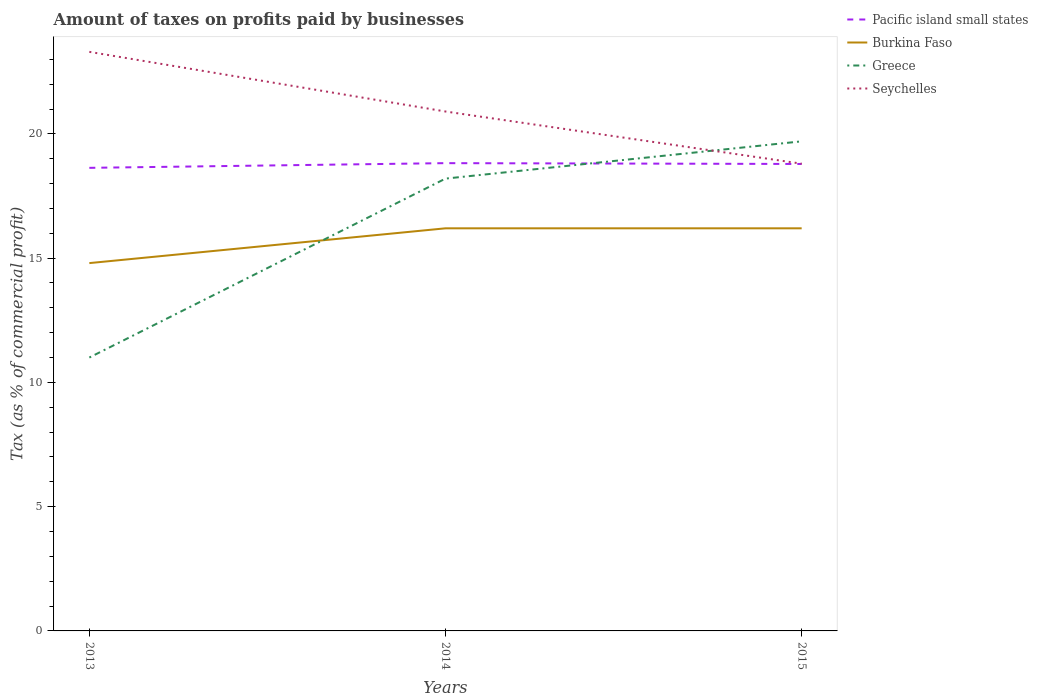Across all years, what is the maximum percentage of taxes paid by businesses in Greece?
Give a very brief answer. 11. In which year was the percentage of taxes paid by businesses in Seychelles maximum?
Offer a terse response. 2015. What is the total percentage of taxes paid by businesses in Seychelles in the graph?
Your answer should be very brief. 4.5. What is the difference between the highest and the second highest percentage of taxes paid by businesses in Burkina Faso?
Your answer should be compact. 1.4. What is the difference between the highest and the lowest percentage of taxes paid by businesses in Pacific island small states?
Give a very brief answer. 2. Is the percentage of taxes paid by businesses in Seychelles strictly greater than the percentage of taxes paid by businesses in Pacific island small states over the years?
Make the answer very short. No. Does the graph contain any zero values?
Your answer should be compact. No. Does the graph contain grids?
Give a very brief answer. No. How many legend labels are there?
Ensure brevity in your answer.  4. How are the legend labels stacked?
Your response must be concise. Vertical. What is the title of the graph?
Offer a terse response. Amount of taxes on profits paid by businesses. What is the label or title of the Y-axis?
Offer a very short reply. Tax (as % of commercial profit). What is the Tax (as % of commercial profit) of Pacific island small states in 2013?
Your answer should be very brief. 18.63. What is the Tax (as % of commercial profit) in Greece in 2013?
Ensure brevity in your answer.  11. What is the Tax (as % of commercial profit) of Seychelles in 2013?
Offer a very short reply. 23.3. What is the Tax (as % of commercial profit) of Pacific island small states in 2014?
Your answer should be compact. 18.82. What is the Tax (as % of commercial profit) in Greece in 2014?
Give a very brief answer. 18.2. What is the Tax (as % of commercial profit) in Seychelles in 2014?
Offer a very short reply. 20.9. What is the Tax (as % of commercial profit) in Pacific island small states in 2015?
Provide a succinct answer. 18.79. What is the Tax (as % of commercial profit) of Burkina Faso in 2015?
Ensure brevity in your answer.  16.2. What is the Tax (as % of commercial profit) of Seychelles in 2015?
Your answer should be compact. 18.8. Across all years, what is the maximum Tax (as % of commercial profit) of Pacific island small states?
Ensure brevity in your answer.  18.82. Across all years, what is the maximum Tax (as % of commercial profit) of Seychelles?
Make the answer very short. 23.3. Across all years, what is the minimum Tax (as % of commercial profit) of Pacific island small states?
Your answer should be compact. 18.63. Across all years, what is the minimum Tax (as % of commercial profit) in Burkina Faso?
Keep it short and to the point. 14.8. What is the total Tax (as % of commercial profit) of Pacific island small states in the graph?
Provide a short and direct response. 56.24. What is the total Tax (as % of commercial profit) in Burkina Faso in the graph?
Provide a short and direct response. 47.2. What is the total Tax (as % of commercial profit) in Greece in the graph?
Your answer should be very brief. 48.9. What is the difference between the Tax (as % of commercial profit) of Pacific island small states in 2013 and that in 2014?
Your answer should be very brief. -0.19. What is the difference between the Tax (as % of commercial profit) of Pacific island small states in 2013 and that in 2015?
Offer a very short reply. -0.16. What is the difference between the Tax (as % of commercial profit) of Seychelles in 2013 and that in 2015?
Your response must be concise. 4.5. What is the difference between the Tax (as % of commercial profit) of Pacific island small states in 2014 and that in 2015?
Provide a succinct answer. 0.03. What is the difference between the Tax (as % of commercial profit) in Greece in 2014 and that in 2015?
Ensure brevity in your answer.  -1.5. What is the difference between the Tax (as % of commercial profit) of Seychelles in 2014 and that in 2015?
Ensure brevity in your answer.  2.1. What is the difference between the Tax (as % of commercial profit) of Pacific island small states in 2013 and the Tax (as % of commercial profit) of Burkina Faso in 2014?
Give a very brief answer. 2.43. What is the difference between the Tax (as % of commercial profit) of Pacific island small states in 2013 and the Tax (as % of commercial profit) of Greece in 2014?
Provide a succinct answer. 0.43. What is the difference between the Tax (as % of commercial profit) of Pacific island small states in 2013 and the Tax (as % of commercial profit) of Seychelles in 2014?
Your answer should be compact. -2.27. What is the difference between the Tax (as % of commercial profit) in Burkina Faso in 2013 and the Tax (as % of commercial profit) in Greece in 2014?
Offer a very short reply. -3.4. What is the difference between the Tax (as % of commercial profit) in Pacific island small states in 2013 and the Tax (as % of commercial profit) in Burkina Faso in 2015?
Give a very brief answer. 2.43. What is the difference between the Tax (as % of commercial profit) in Pacific island small states in 2013 and the Tax (as % of commercial profit) in Greece in 2015?
Ensure brevity in your answer.  -1.07. What is the difference between the Tax (as % of commercial profit) in Pacific island small states in 2013 and the Tax (as % of commercial profit) in Seychelles in 2015?
Offer a terse response. -0.17. What is the difference between the Tax (as % of commercial profit) in Burkina Faso in 2013 and the Tax (as % of commercial profit) in Seychelles in 2015?
Offer a very short reply. -4. What is the difference between the Tax (as % of commercial profit) of Pacific island small states in 2014 and the Tax (as % of commercial profit) of Burkina Faso in 2015?
Offer a very short reply. 2.62. What is the difference between the Tax (as % of commercial profit) of Pacific island small states in 2014 and the Tax (as % of commercial profit) of Greece in 2015?
Provide a short and direct response. -0.88. What is the difference between the Tax (as % of commercial profit) of Pacific island small states in 2014 and the Tax (as % of commercial profit) of Seychelles in 2015?
Ensure brevity in your answer.  0.02. What is the difference between the Tax (as % of commercial profit) in Greece in 2014 and the Tax (as % of commercial profit) in Seychelles in 2015?
Give a very brief answer. -0.6. What is the average Tax (as % of commercial profit) in Pacific island small states per year?
Provide a short and direct response. 18.75. What is the average Tax (as % of commercial profit) in Burkina Faso per year?
Provide a succinct answer. 15.73. What is the average Tax (as % of commercial profit) in Seychelles per year?
Provide a succinct answer. 21. In the year 2013, what is the difference between the Tax (as % of commercial profit) of Pacific island small states and Tax (as % of commercial profit) of Burkina Faso?
Ensure brevity in your answer.  3.83. In the year 2013, what is the difference between the Tax (as % of commercial profit) of Pacific island small states and Tax (as % of commercial profit) of Greece?
Offer a very short reply. 7.63. In the year 2013, what is the difference between the Tax (as % of commercial profit) of Pacific island small states and Tax (as % of commercial profit) of Seychelles?
Keep it short and to the point. -4.67. In the year 2013, what is the difference between the Tax (as % of commercial profit) of Burkina Faso and Tax (as % of commercial profit) of Greece?
Offer a very short reply. 3.8. In the year 2013, what is the difference between the Tax (as % of commercial profit) of Burkina Faso and Tax (as % of commercial profit) of Seychelles?
Offer a terse response. -8.5. In the year 2013, what is the difference between the Tax (as % of commercial profit) in Greece and Tax (as % of commercial profit) in Seychelles?
Keep it short and to the point. -12.3. In the year 2014, what is the difference between the Tax (as % of commercial profit) of Pacific island small states and Tax (as % of commercial profit) of Burkina Faso?
Give a very brief answer. 2.62. In the year 2014, what is the difference between the Tax (as % of commercial profit) in Pacific island small states and Tax (as % of commercial profit) in Greece?
Offer a terse response. 0.62. In the year 2014, what is the difference between the Tax (as % of commercial profit) of Pacific island small states and Tax (as % of commercial profit) of Seychelles?
Keep it short and to the point. -2.08. In the year 2014, what is the difference between the Tax (as % of commercial profit) in Burkina Faso and Tax (as % of commercial profit) in Seychelles?
Give a very brief answer. -4.7. In the year 2015, what is the difference between the Tax (as % of commercial profit) of Pacific island small states and Tax (as % of commercial profit) of Burkina Faso?
Your response must be concise. 2.59. In the year 2015, what is the difference between the Tax (as % of commercial profit) of Pacific island small states and Tax (as % of commercial profit) of Greece?
Keep it short and to the point. -0.91. In the year 2015, what is the difference between the Tax (as % of commercial profit) in Pacific island small states and Tax (as % of commercial profit) in Seychelles?
Give a very brief answer. -0.01. In the year 2015, what is the difference between the Tax (as % of commercial profit) in Burkina Faso and Tax (as % of commercial profit) in Seychelles?
Give a very brief answer. -2.6. What is the ratio of the Tax (as % of commercial profit) in Pacific island small states in 2013 to that in 2014?
Provide a short and direct response. 0.99. What is the ratio of the Tax (as % of commercial profit) in Burkina Faso in 2013 to that in 2014?
Provide a succinct answer. 0.91. What is the ratio of the Tax (as % of commercial profit) in Greece in 2013 to that in 2014?
Your answer should be very brief. 0.6. What is the ratio of the Tax (as % of commercial profit) in Seychelles in 2013 to that in 2014?
Keep it short and to the point. 1.11. What is the ratio of the Tax (as % of commercial profit) in Burkina Faso in 2013 to that in 2015?
Your answer should be very brief. 0.91. What is the ratio of the Tax (as % of commercial profit) of Greece in 2013 to that in 2015?
Give a very brief answer. 0.56. What is the ratio of the Tax (as % of commercial profit) of Seychelles in 2013 to that in 2015?
Give a very brief answer. 1.24. What is the ratio of the Tax (as % of commercial profit) of Greece in 2014 to that in 2015?
Offer a terse response. 0.92. What is the ratio of the Tax (as % of commercial profit) of Seychelles in 2014 to that in 2015?
Give a very brief answer. 1.11. What is the difference between the highest and the second highest Tax (as % of commercial profit) of Greece?
Ensure brevity in your answer.  1.5. What is the difference between the highest and the second highest Tax (as % of commercial profit) of Seychelles?
Provide a short and direct response. 2.4. What is the difference between the highest and the lowest Tax (as % of commercial profit) in Pacific island small states?
Provide a succinct answer. 0.19. What is the difference between the highest and the lowest Tax (as % of commercial profit) of Burkina Faso?
Keep it short and to the point. 1.4. What is the difference between the highest and the lowest Tax (as % of commercial profit) in Greece?
Ensure brevity in your answer.  8.7. 